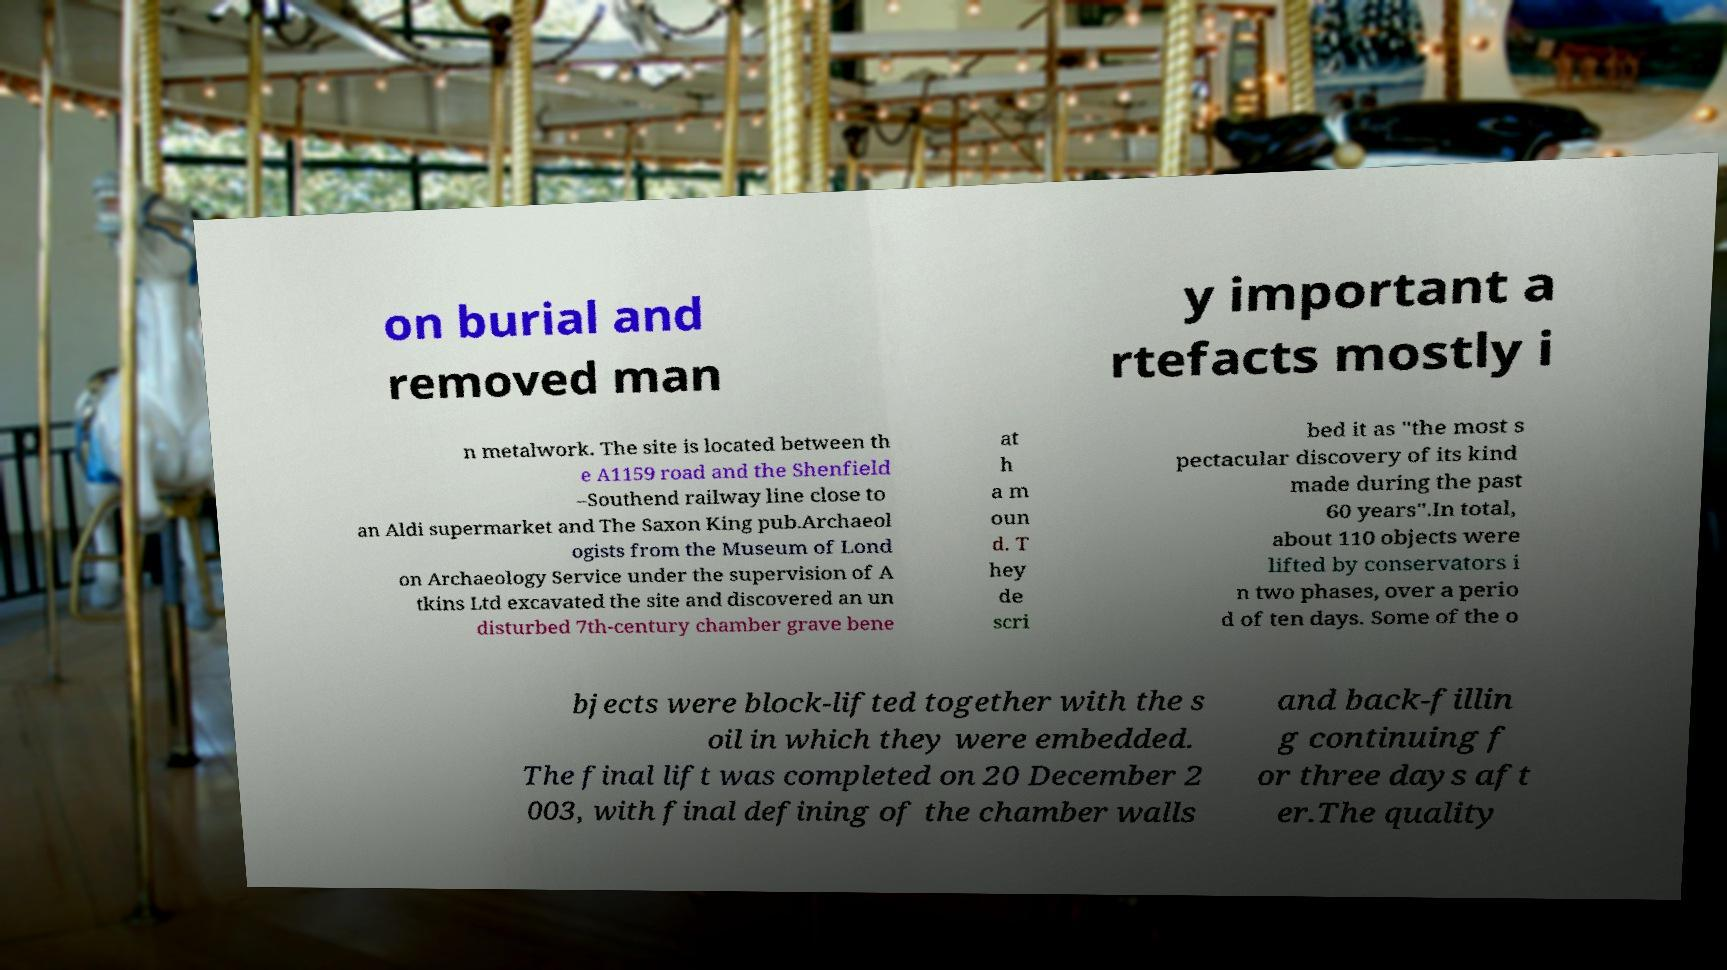Could you extract and type out the text from this image? on burial and removed man y important a rtefacts mostly i n metalwork. The site is located between th e A1159 road and the Shenfield –Southend railway line close to an Aldi supermarket and The Saxon King pub.Archaeol ogists from the Museum of Lond on Archaeology Service under the supervision of A tkins Ltd excavated the site and discovered an un disturbed 7th-century chamber grave bene at h a m oun d. T hey de scri bed it as "the most s pectacular discovery of its kind made during the past 60 years".In total, about 110 objects were lifted by conservators i n two phases, over a perio d of ten days. Some of the o bjects were block-lifted together with the s oil in which they were embedded. The final lift was completed on 20 December 2 003, with final defining of the chamber walls and back-fillin g continuing f or three days aft er.The quality 